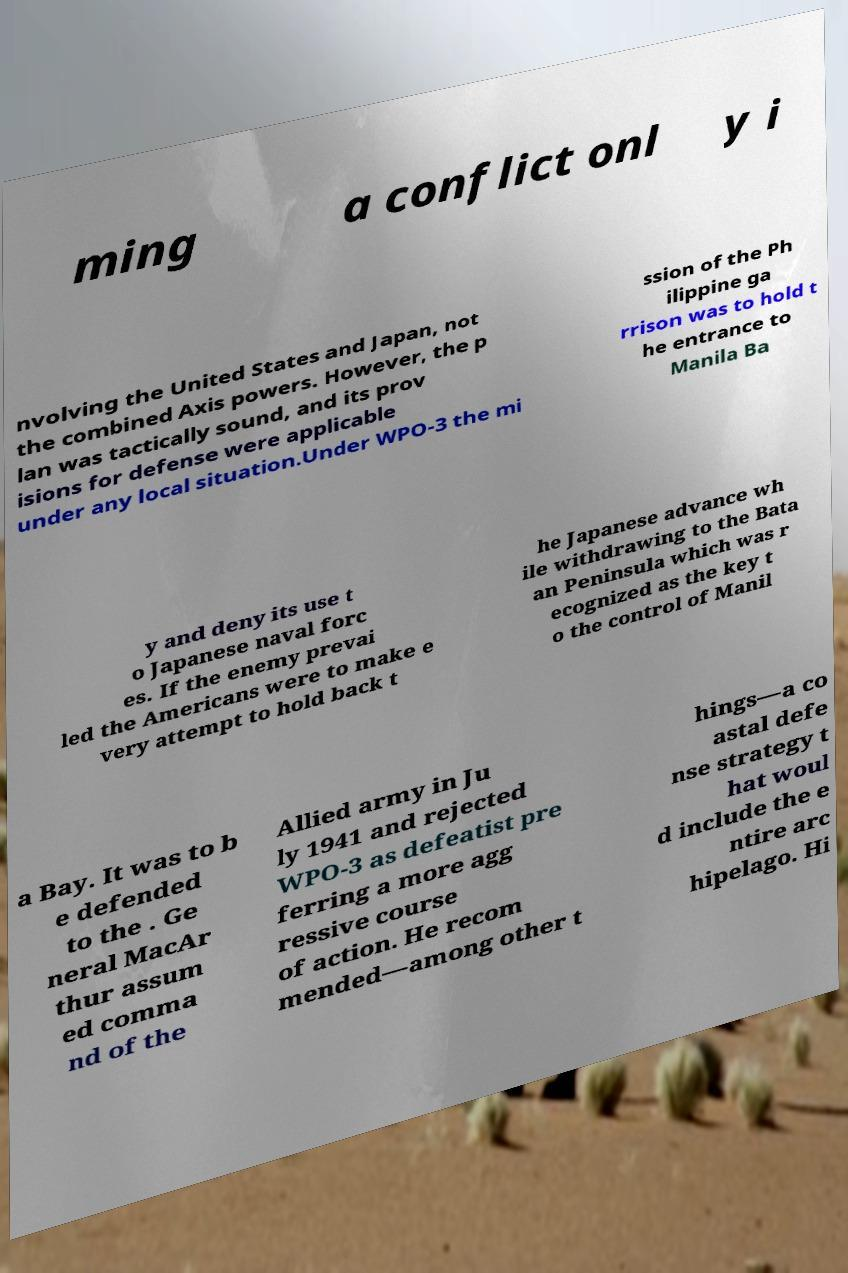Could you assist in decoding the text presented in this image and type it out clearly? ming a conflict onl y i nvolving the United States and Japan, not the combined Axis powers. However, the p lan was tactically sound, and its prov isions for defense were applicable under any local situation.Under WPO-3 the mi ssion of the Ph ilippine ga rrison was to hold t he entrance to Manila Ba y and deny its use t o Japanese naval forc es. If the enemy prevai led the Americans were to make e very attempt to hold back t he Japanese advance wh ile withdrawing to the Bata an Peninsula which was r ecognized as the key t o the control of Manil a Bay. It was to b e defended to the . Ge neral MacAr thur assum ed comma nd of the Allied army in Ju ly 1941 and rejected WPO-3 as defeatist pre ferring a more agg ressive course of action. He recom mended—among other t hings—a co astal defe nse strategy t hat woul d include the e ntire arc hipelago. Hi 